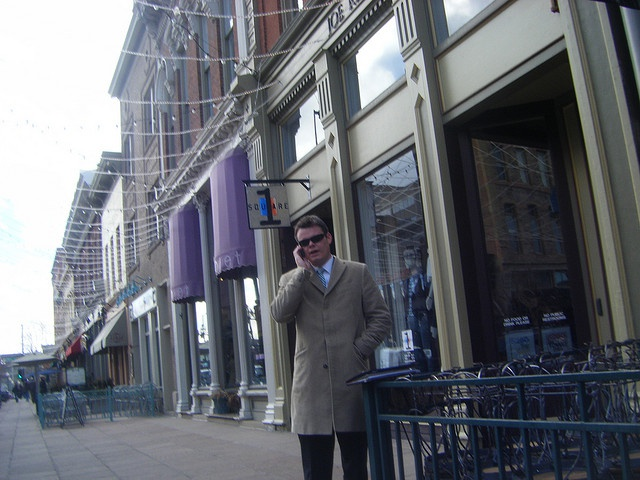Describe the objects in this image and their specific colors. I can see people in white, black, gray, and darkgray tones, chair in white, black, gray, and darkgray tones, people in white, black, gray, and darkblue tones, people in white, navy, black, blue, and gray tones, and people in white, navy, black, darkblue, and gray tones in this image. 